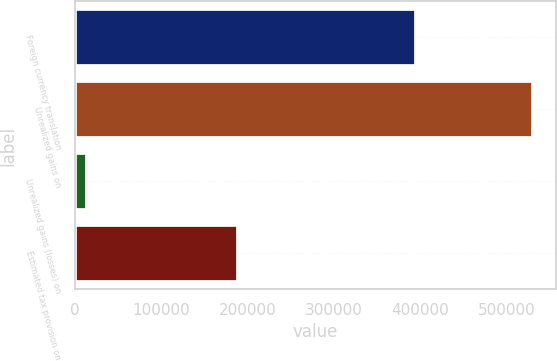<chart> <loc_0><loc_0><loc_500><loc_500><bar_chart><fcel>Foreign currency translation<fcel>Unrealized gains on<fcel>Unrealized gains (losses) on<fcel>Estimated tax provision on<nl><fcel>394835<fcel>531181<fcel>13560<fcel>188262<nl></chart> 